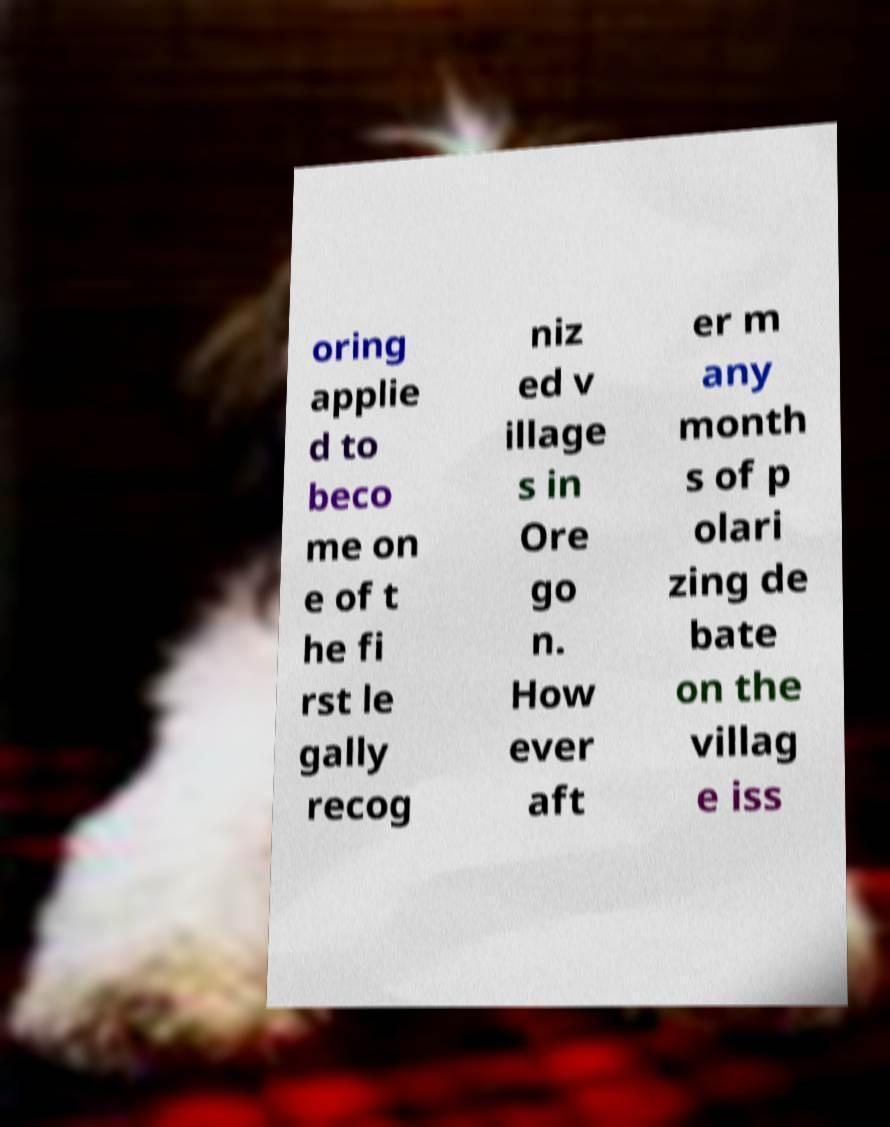Can you accurately transcribe the text from the provided image for me? oring applie d to beco me on e of t he fi rst le gally recog niz ed v illage s in Ore go n. How ever aft er m any month s of p olari zing de bate on the villag e iss 